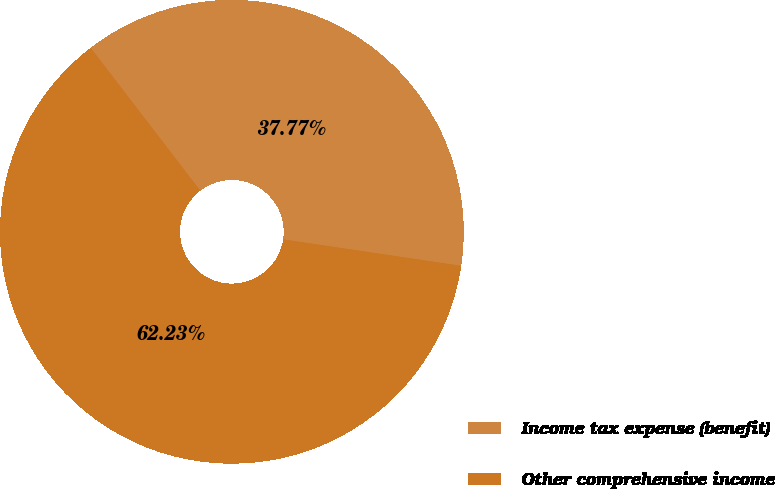Convert chart. <chart><loc_0><loc_0><loc_500><loc_500><pie_chart><fcel>Income tax expense (benefit)<fcel>Other comprehensive income<nl><fcel>37.77%<fcel>62.23%<nl></chart> 